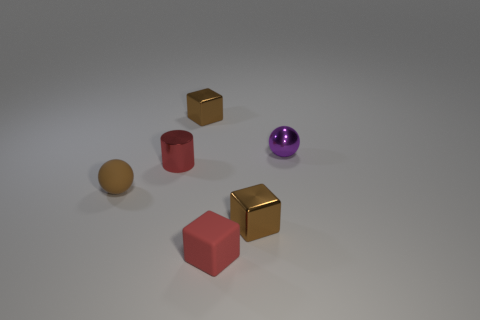There is a metallic block behind the purple ball; what color is it?
Offer a very short reply. Brown. There is a small cylinder; does it have the same color as the small rubber thing to the left of the matte cube?
Keep it short and to the point. No. Is the number of big cyan rubber cubes less than the number of purple metal balls?
Offer a terse response. Yes. Do the ball behind the small brown matte ball and the tiny metallic cylinder have the same color?
Your answer should be very brief. No. How many brown cubes have the same size as the brown sphere?
Your answer should be compact. 2. Are there any rubber spheres of the same color as the tiny shiny cylinder?
Make the answer very short. No. Is the material of the small purple object the same as the small red cylinder?
Your answer should be very brief. Yes. How many other rubber things have the same shape as the brown matte object?
Ensure brevity in your answer.  0. There is a purple thing that is the same material as the cylinder; what shape is it?
Your answer should be compact. Sphere. What color is the metal block behind the small sphere in front of the shiny sphere?
Your answer should be compact. Brown. 